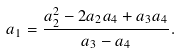Convert formula to latex. <formula><loc_0><loc_0><loc_500><loc_500>a _ { 1 } = \frac { a _ { 2 } ^ { 2 } - 2 a _ { 2 } a _ { 4 } + a _ { 3 } a _ { 4 } } { a _ { 3 } - a _ { 4 } } .</formula> 